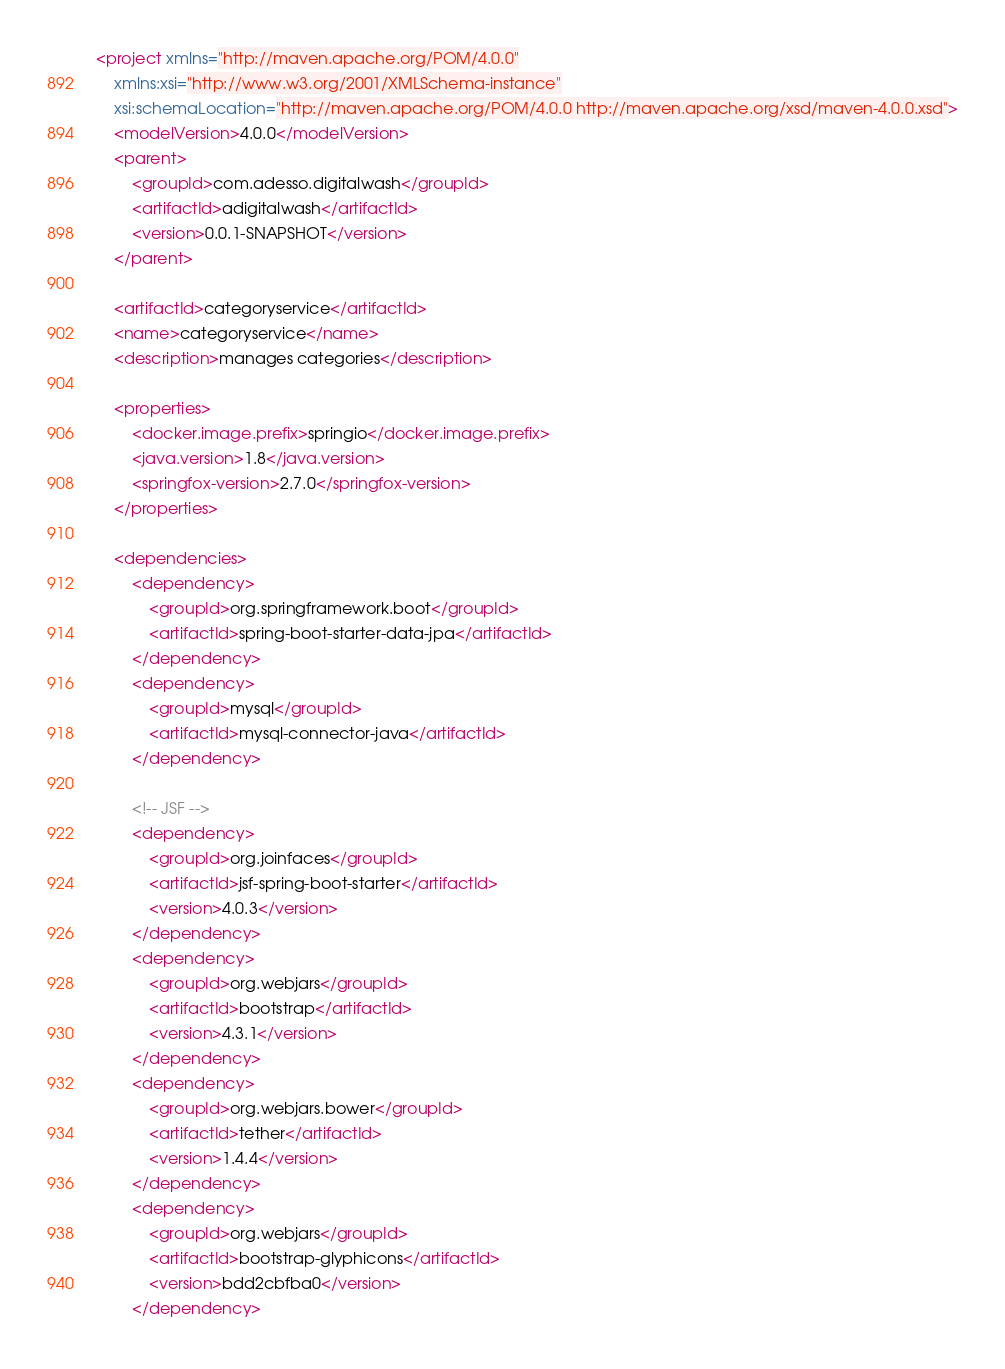<code> <loc_0><loc_0><loc_500><loc_500><_XML_><project xmlns="http://maven.apache.org/POM/4.0.0"
	xmlns:xsi="http://www.w3.org/2001/XMLSchema-instance"
	xsi:schemaLocation="http://maven.apache.org/POM/4.0.0 http://maven.apache.org/xsd/maven-4.0.0.xsd">
	<modelVersion>4.0.0</modelVersion>
	<parent>
		<groupId>com.adesso.digitalwash</groupId>
		<artifactId>adigitalwash</artifactId>
		<version>0.0.1-SNAPSHOT</version>
	</parent>

	<artifactId>categoryservice</artifactId>
	<name>categoryservice</name>
	<description>manages categories</description>

	<properties>
		<docker.image.prefix>springio</docker.image.prefix>
		<java.version>1.8</java.version>
		<springfox-version>2.7.0</springfox-version>
	</properties>

	<dependencies>
		<dependency>
			<groupId>org.springframework.boot</groupId>
			<artifactId>spring-boot-starter-data-jpa</artifactId>
		</dependency>
		<dependency>
			<groupId>mysql</groupId>
			<artifactId>mysql-connector-java</artifactId>
		</dependency>

		<!-- JSF -->
		<dependency>
			<groupId>org.joinfaces</groupId>
			<artifactId>jsf-spring-boot-starter</artifactId>
			<version>4.0.3</version>
		</dependency>
		<dependency>
			<groupId>org.webjars</groupId>
			<artifactId>bootstrap</artifactId>
			<version>4.3.1</version>
		</dependency>
		<dependency>
			<groupId>org.webjars.bower</groupId>
			<artifactId>tether</artifactId>
			<version>1.4.4</version>
		</dependency>
		<dependency>
			<groupId>org.webjars</groupId>
			<artifactId>bootstrap-glyphicons</artifactId>
			<version>bdd2cbfba0</version>
		</dependency></code> 